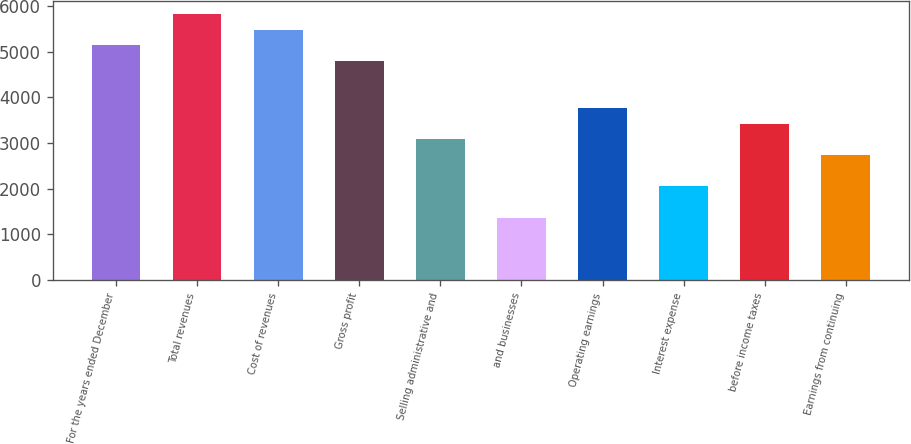<chart> <loc_0><loc_0><loc_500><loc_500><bar_chart><fcel>For the years ended December<fcel>Total revenues<fcel>Cost of revenues<fcel>Gross profit<fcel>Selling administrative and<fcel>and businesses<fcel>Operating earnings<fcel>Interest expense<fcel>before income taxes<fcel>Earnings from continuing<nl><fcel>5133.24<fcel>5817.66<fcel>5475.45<fcel>4791.03<fcel>3079.98<fcel>1368.93<fcel>3764.4<fcel>2053.35<fcel>3422.19<fcel>2737.77<nl></chart> 